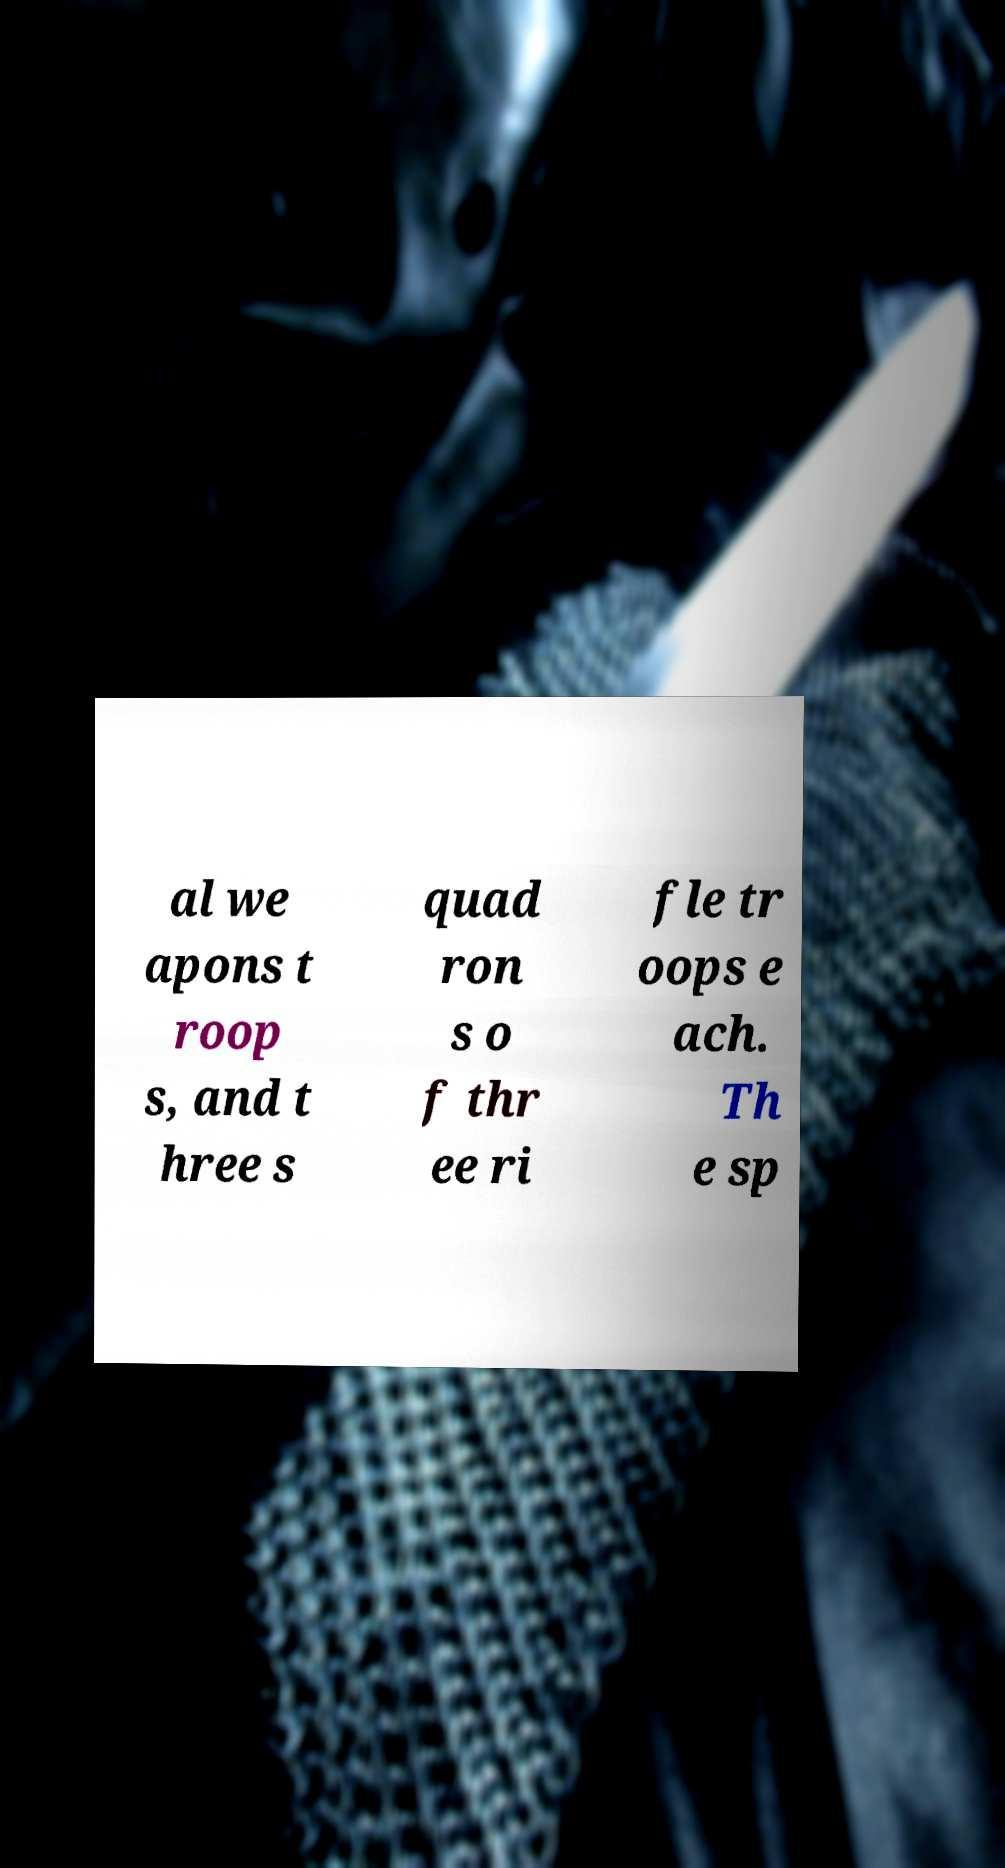Please identify and transcribe the text found in this image. al we apons t roop s, and t hree s quad ron s o f thr ee ri fle tr oops e ach. Th e sp 